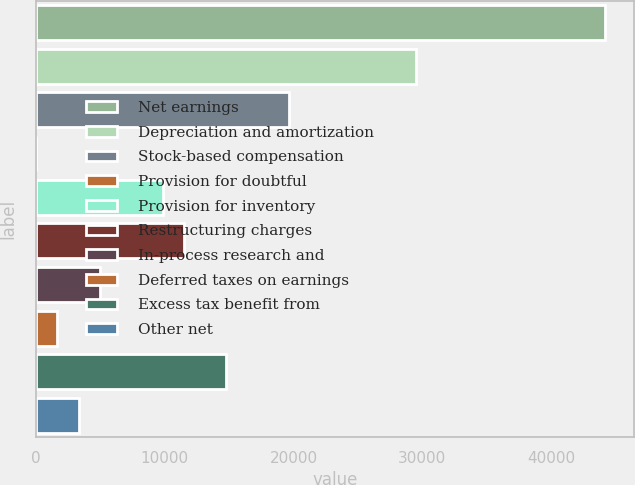Convert chart to OTSL. <chart><loc_0><loc_0><loc_500><loc_500><bar_chart><fcel>Net earnings<fcel>Depreciation and amortization<fcel>Stock-based compensation<fcel>Provision for doubtful<fcel>Provision for inventory<fcel>Restructuring charges<fcel>In-process research and<fcel>Deferred taxes on earnings<fcel>Excess tax benefit from<fcel>Other net<nl><fcel>44200.1<fcel>29482.4<fcel>19670.6<fcel>47<fcel>9858.8<fcel>11494.1<fcel>4952.9<fcel>1682.3<fcel>14764.7<fcel>3317.6<nl></chart> 